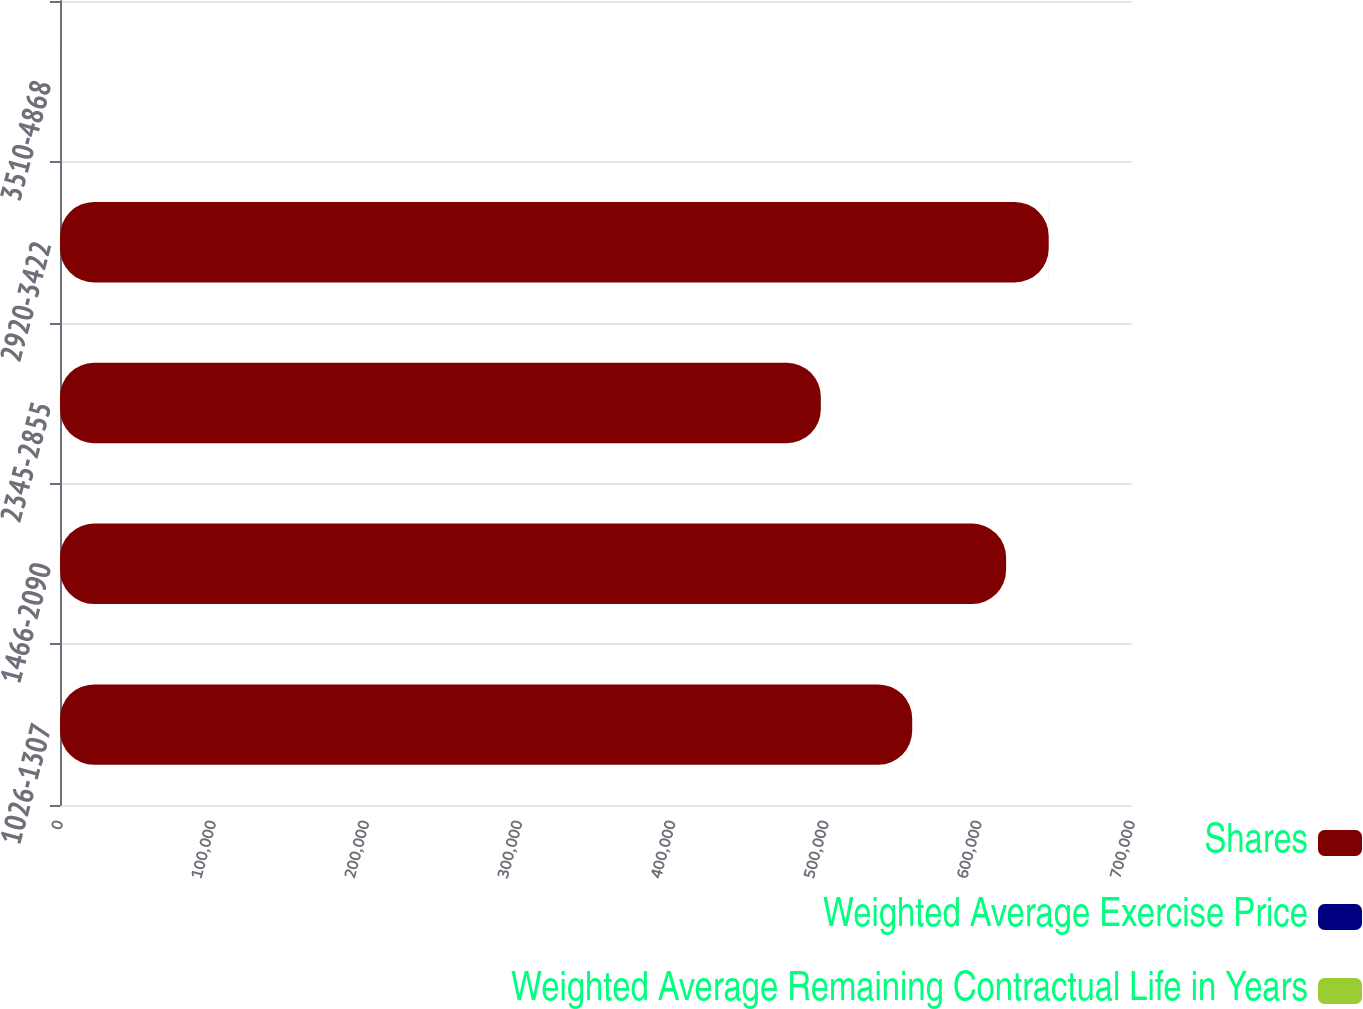Convert chart. <chart><loc_0><loc_0><loc_500><loc_500><stacked_bar_chart><ecel><fcel>1026-1307<fcel>1466-2090<fcel>2345-2855<fcel>2920-3422<fcel>3510-4868<nl><fcel>Shares<fcel>556478<fcel>617788<fcel>496815<fcel>645621<fcel>21.155<nl><fcel>Weighted Average Exercise Price<fcel>4.09<fcel>4.69<fcel>6.6<fcel>8.64<fcel>8.34<nl><fcel>Weighted Average Remaining Contractual Life in Years<fcel>11.85<fcel>16.12<fcel>26.19<fcel>33.25<fcel>38.64<nl></chart> 